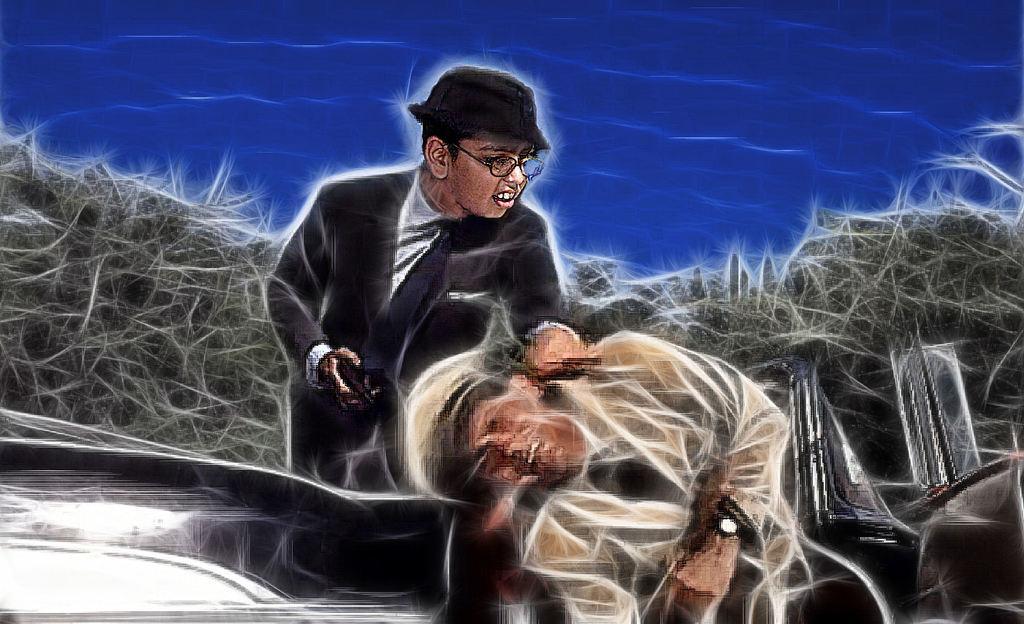Can you describe this image briefly? This is an animated image, in this picture we can see people and objects. In the background of the image it is blue. 